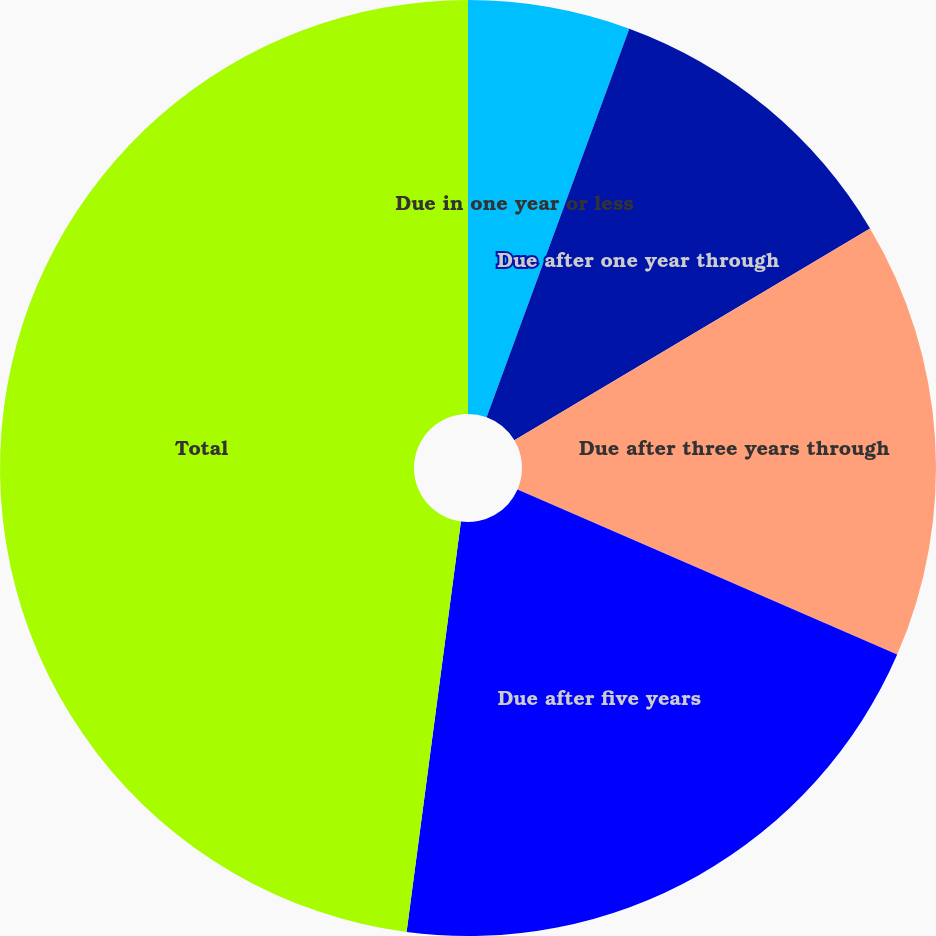Convert chart to OTSL. <chart><loc_0><loc_0><loc_500><loc_500><pie_chart><fcel>Due in one year or less<fcel>Due after one year through<fcel>Due after three years through<fcel>Due after five years<fcel>Total<nl><fcel>5.6%<fcel>10.85%<fcel>15.08%<fcel>20.57%<fcel>47.91%<nl></chart> 